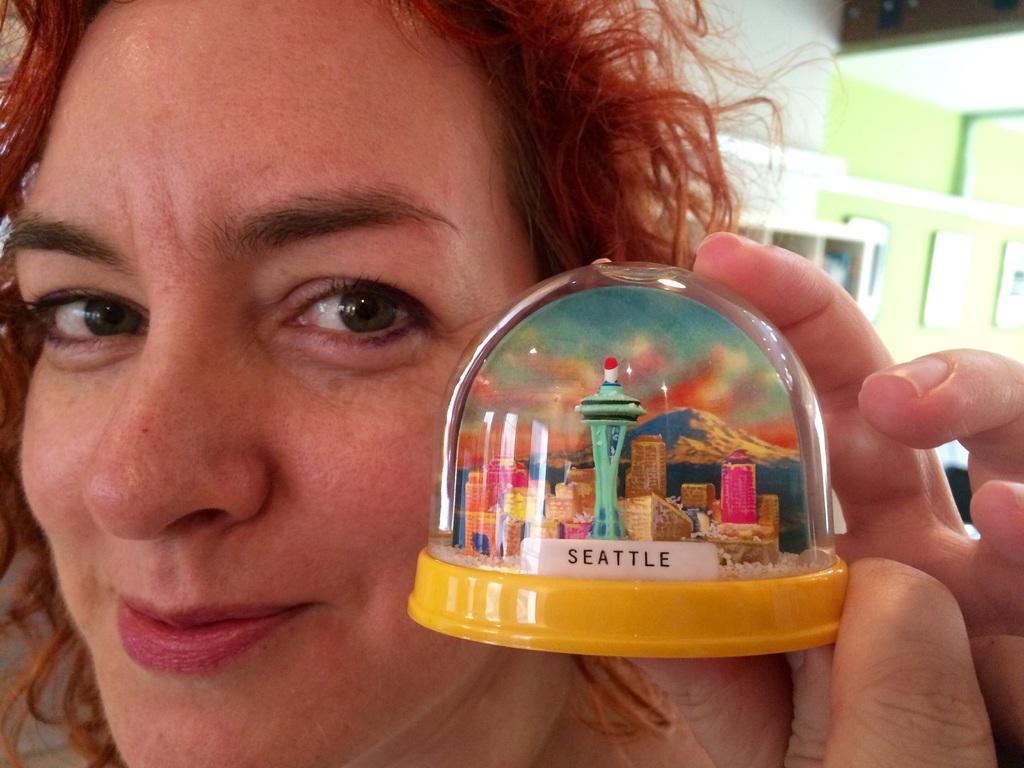What city is in the globe?
Your answer should be very brief. Seattle. What city is inside the snow globe?
Make the answer very short. Seattle. 